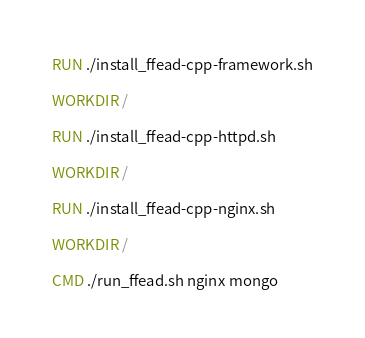<code> <loc_0><loc_0><loc_500><loc_500><_Dockerfile_>
RUN ./install_ffead-cpp-framework.sh

WORKDIR /

RUN ./install_ffead-cpp-httpd.sh

WORKDIR /

RUN ./install_ffead-cpp-nginx.sh

WORKDIR /

CMD ./run_ffead.sh nginx mongo
</code> 